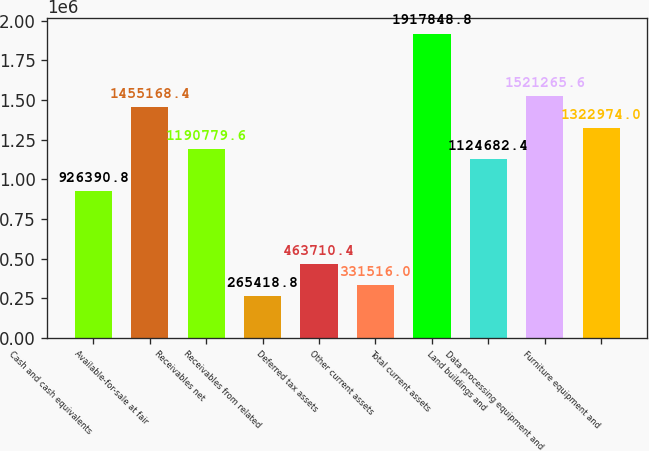Convert chart. <chart><loc_0><loc_0><loc_500><loc_500><bar_chart><fcel>Cash and cash equivalents<fcel>Available-for-sale at fair<fcel>Receivables net<fcel>Receivables from related<fcel>Deferred tax assets<fcel>Other current assets<fcel>Total current assets<fcel>Land buildings and<fcel>Data processing equipment and<fcel>Furniture equipment and<nl><fcel>926391<fcel>1.45517e+06<fcel>1.19078e+06<fcel>265419<fcel>463710<fcel>331516<fcel>1.91785e+06<fcel>1.12468e+06<fcel>1.52127e+06<fcel>1.32297e+06<nl></chart> 